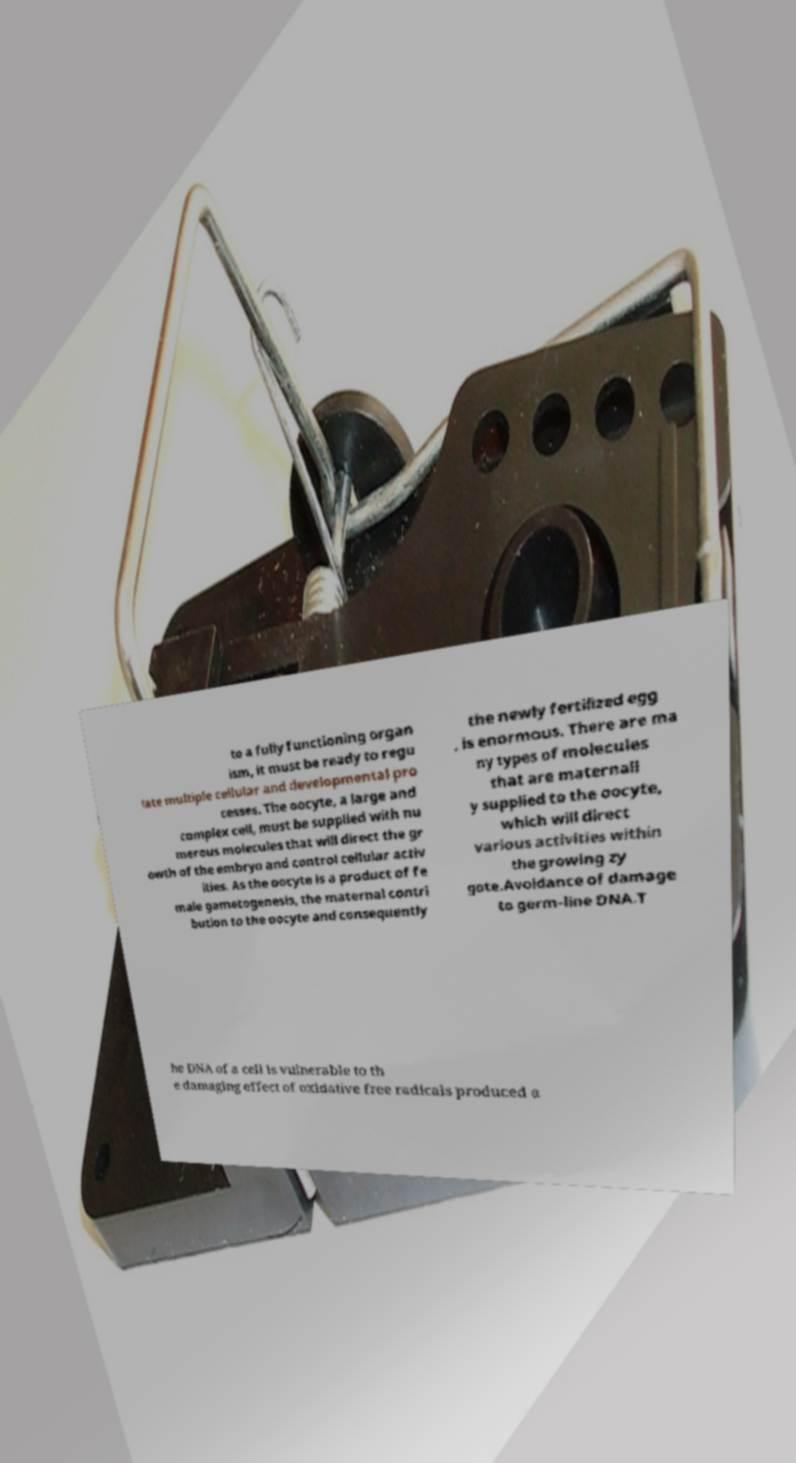Please read and relay the text visible in this image. What does it say? to a fully functioning organ ism, it must be ready to regu late multiple cellular and developmental pro cesses. The oocyte, a large and complex cell, must be supplied with nu merous molecules that will direct the gr owth of the embryo and control cellular activ ities. As the oocyte is a product of fe male gametogenesis, the maternal contri bution to the oocyte and consequently the newly fertilized egg , is enormous. There are ma ny types of molecules that are maternall y supplied to the oocyte, which will direct various activities within the growing zy gote.Avoidance of damage to germ-line DNA.T he DNA of a cell is vulnerable to th e damaging effect of oxidative free radicals produced a 